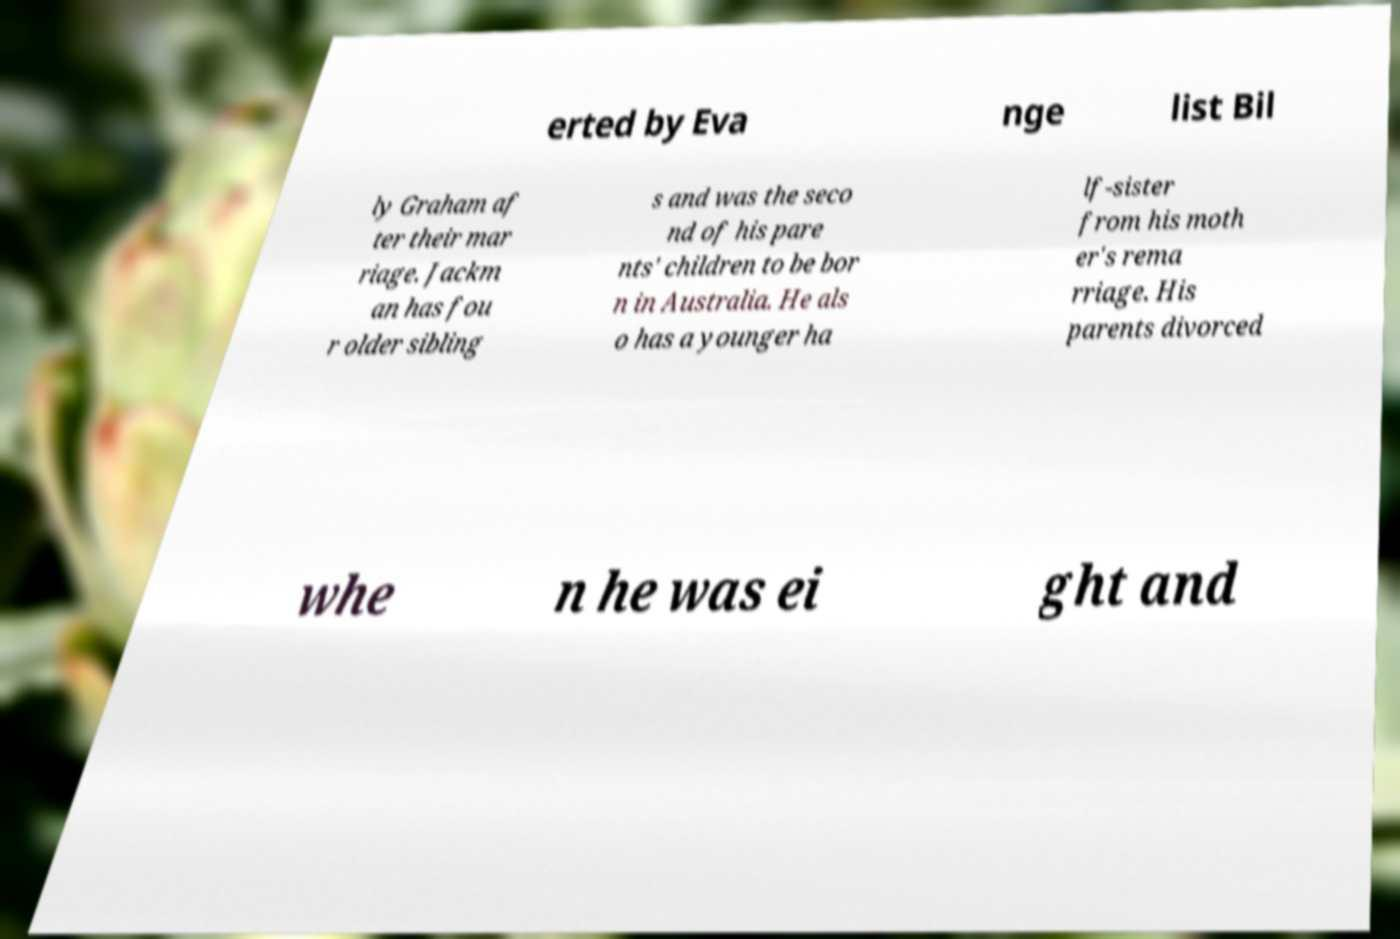Could you assist in decoding the text presented in this image and type it out clearly? erted by Eva nge list Bil ly Graham af ter their mar riage. Jackm an has fou r older sibling s and was the seco nd of his pare nts' children to be bor n in Australia. He als o has a younger ha lf-sister from his moth er's rema rriage. His parents divorced whe n he was ei ght and 